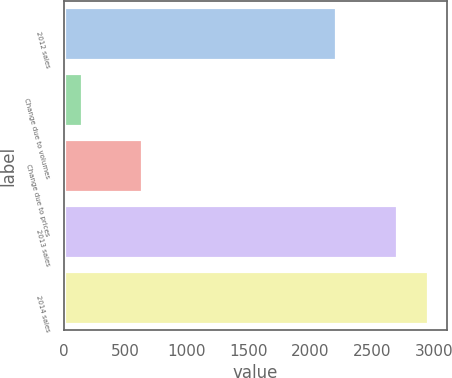Convert chart. <chart><loc_0><loc_0><loc_500><loc_500><bar_chart><fcel>2012 sales<fcel>Change due to volumes<fcel>Change due to prices<fcel>2013 sales<fcel>2014 sales<nl><fcel>2211<fcel>152<fcel>639<fcel>2698<fcel>2956.5<nl></chart> 